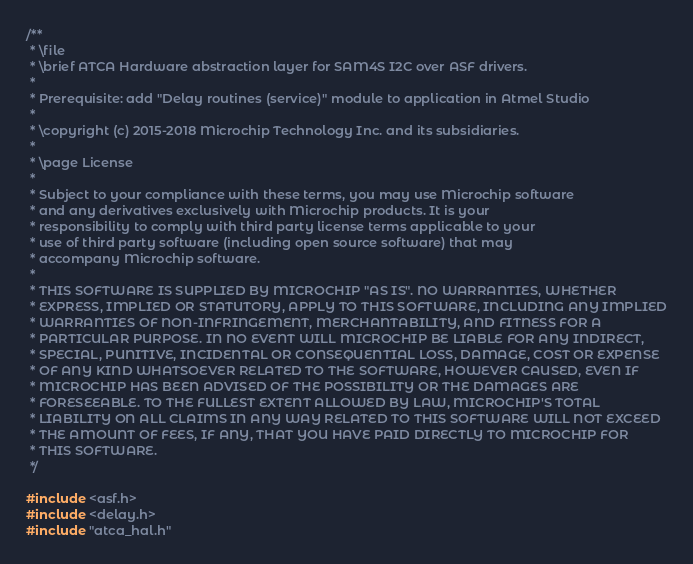Convert code to text. <code><loc_0><loc_0><loc_500><loc_500><_C_>/**
 * \file
 * \brief ATCA Hardware abstraction layer for SAM4S I2C over ASF drivers.
 *
 * Prerequisite: add "Delay routines (service)" module to application in Atmel Studio
 *
 * \copyright (c) 2015-2018 Microchip Technology Inc. and its subsidiaries.
 *
 * \page License
 *
 * Subject to your compliance with these terms, you may use Microchip software
 * and any derivatives exclusively with Microchip products. It is your
 * responsibility to comply with third party license terms applicable to your
 * use of third party software (including open source software) that may
 * accompany Microchip software.
 *
 * THIS SOFTWARE IS SUPPLIED BY MICROCHIP "AS IS". NO WARRANTIES, WHETHER
 * EXPRESS, IMPLIED OR STATUTORY, APPLY TO THIS SOFTWARE, INCLUDING ANY IMPLIED
 * WARRANTIES OF NON-INFRINGEMENT, MERCHANTABILITY, AND FITNESS FOR A
 * PARTICULAR PURPOSE. IN NO EVENT WILL MICROCHIP BE LIABLE FOR ANY INDIRECT,
 * SPECIAL, PUNITIVE, INCIDENTAL OR CONSEQUENTIAL LOSS, DAMAGE, COST OR EXPENSE
 * OF ANY KIND WHATSOEVER RELATED TO THE SOFTWARE, HOWEVER CAUSED, EVEN IF
 * MICROCHIP HAS BEEN ADVISED OF THE POSSIBILITY OR THE DAMAGES ARE
 * FORESEEABLE. TO THE FULLEST EXTENT ALLOWED BY LAW, MICROCHIP'S TOTAL
 * LIABILITY ON ALL CLAIMS IN ANY WAY RELATED TO THIS SOFTWARE WILL NOT EXCEED
 * THE AMOUNT OF FEES, IF ANY, THAT YOU HAVE PAID DIRECTLY TO MICROCHIP FOR
 * THIS SOFTWARE.
 */

#include <asf.h>
#include <delay.h>
#include "atca_hal.h"

</code> 